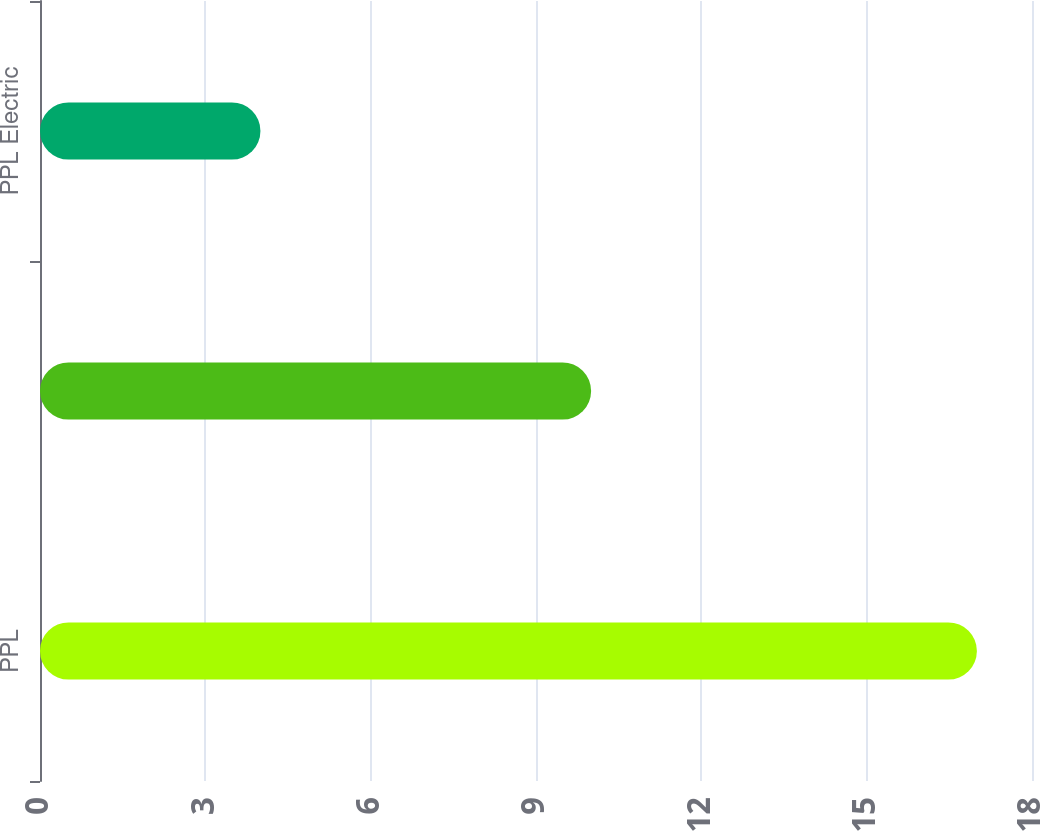Convert chart. <chart><loc_0><loc_0><loc_500><loc_500><bar_chart><fcel>PPL<fcel>PPL Energy Supply<fcel>PPL Electric<nl><fcel>17<fcel>10<fcel>4<nl></chart> 